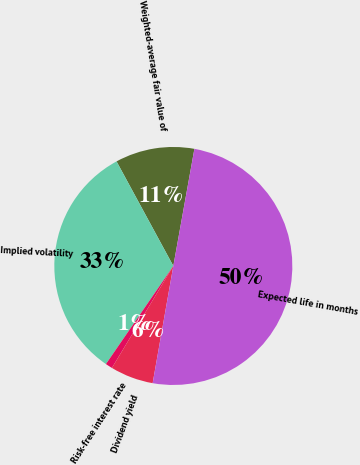<chart> <loc_0><loc_0><loc_500><loc_500><pie_chart><fcel>Weighted-average fair value of<fcel>Implied volatility<fcel>Risk-free interest rate<fcel>Dividend yield<fcel>Expected life in months<nl><fcel>10.75%<fcel>32.5%<fcel>0.95%<fcel>5.85%<fcel>49.94%<nl></chart> 